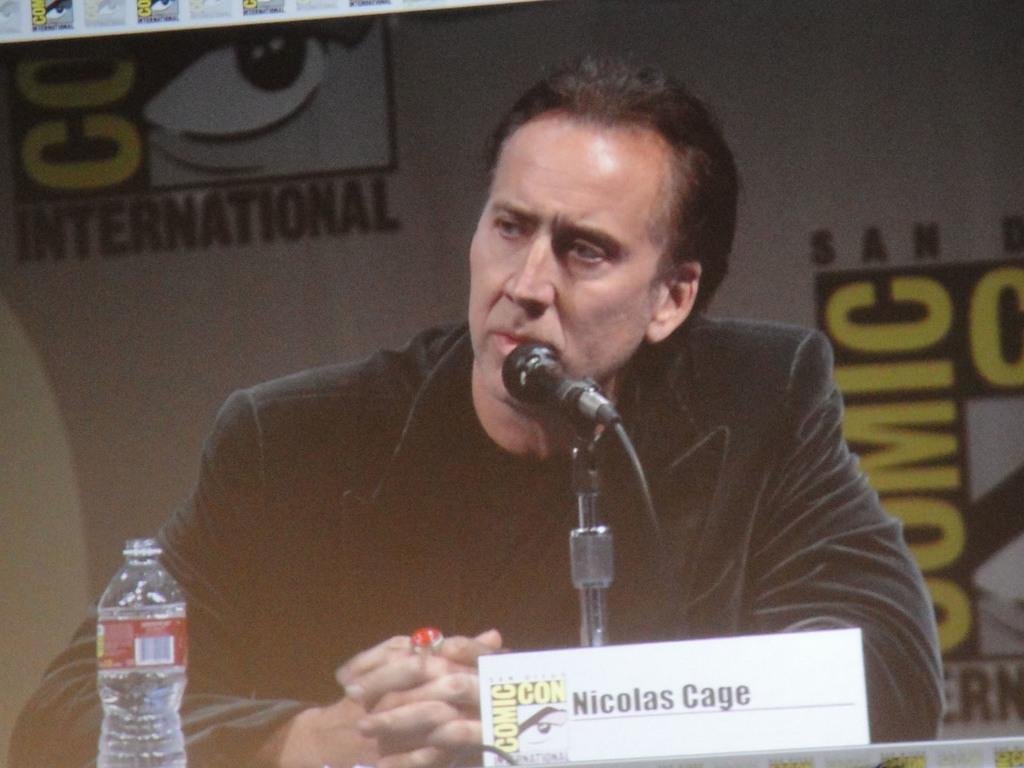Who is the person in the image? There is a man in the image, and his name is Mike. What object can be seen in the image besides the man? There is a bottle in the image. What is in the background of the image? There is a banner in the background of the image. How does the tramp perform a turn in the image? There is no tramp present in the image, so it is not possible to answer that question. 